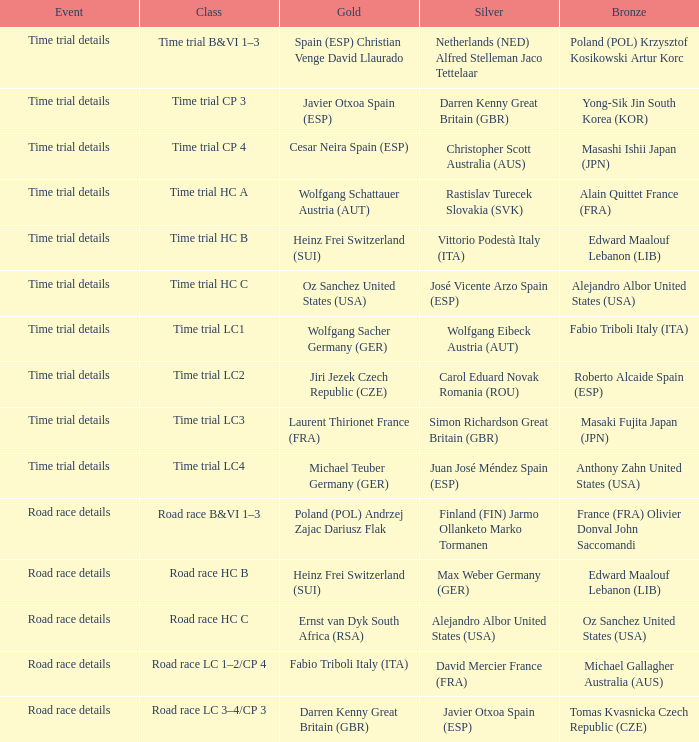In which circumstance does darren kenny representing great britain (gbr) secure a gold medal? Road race details. 